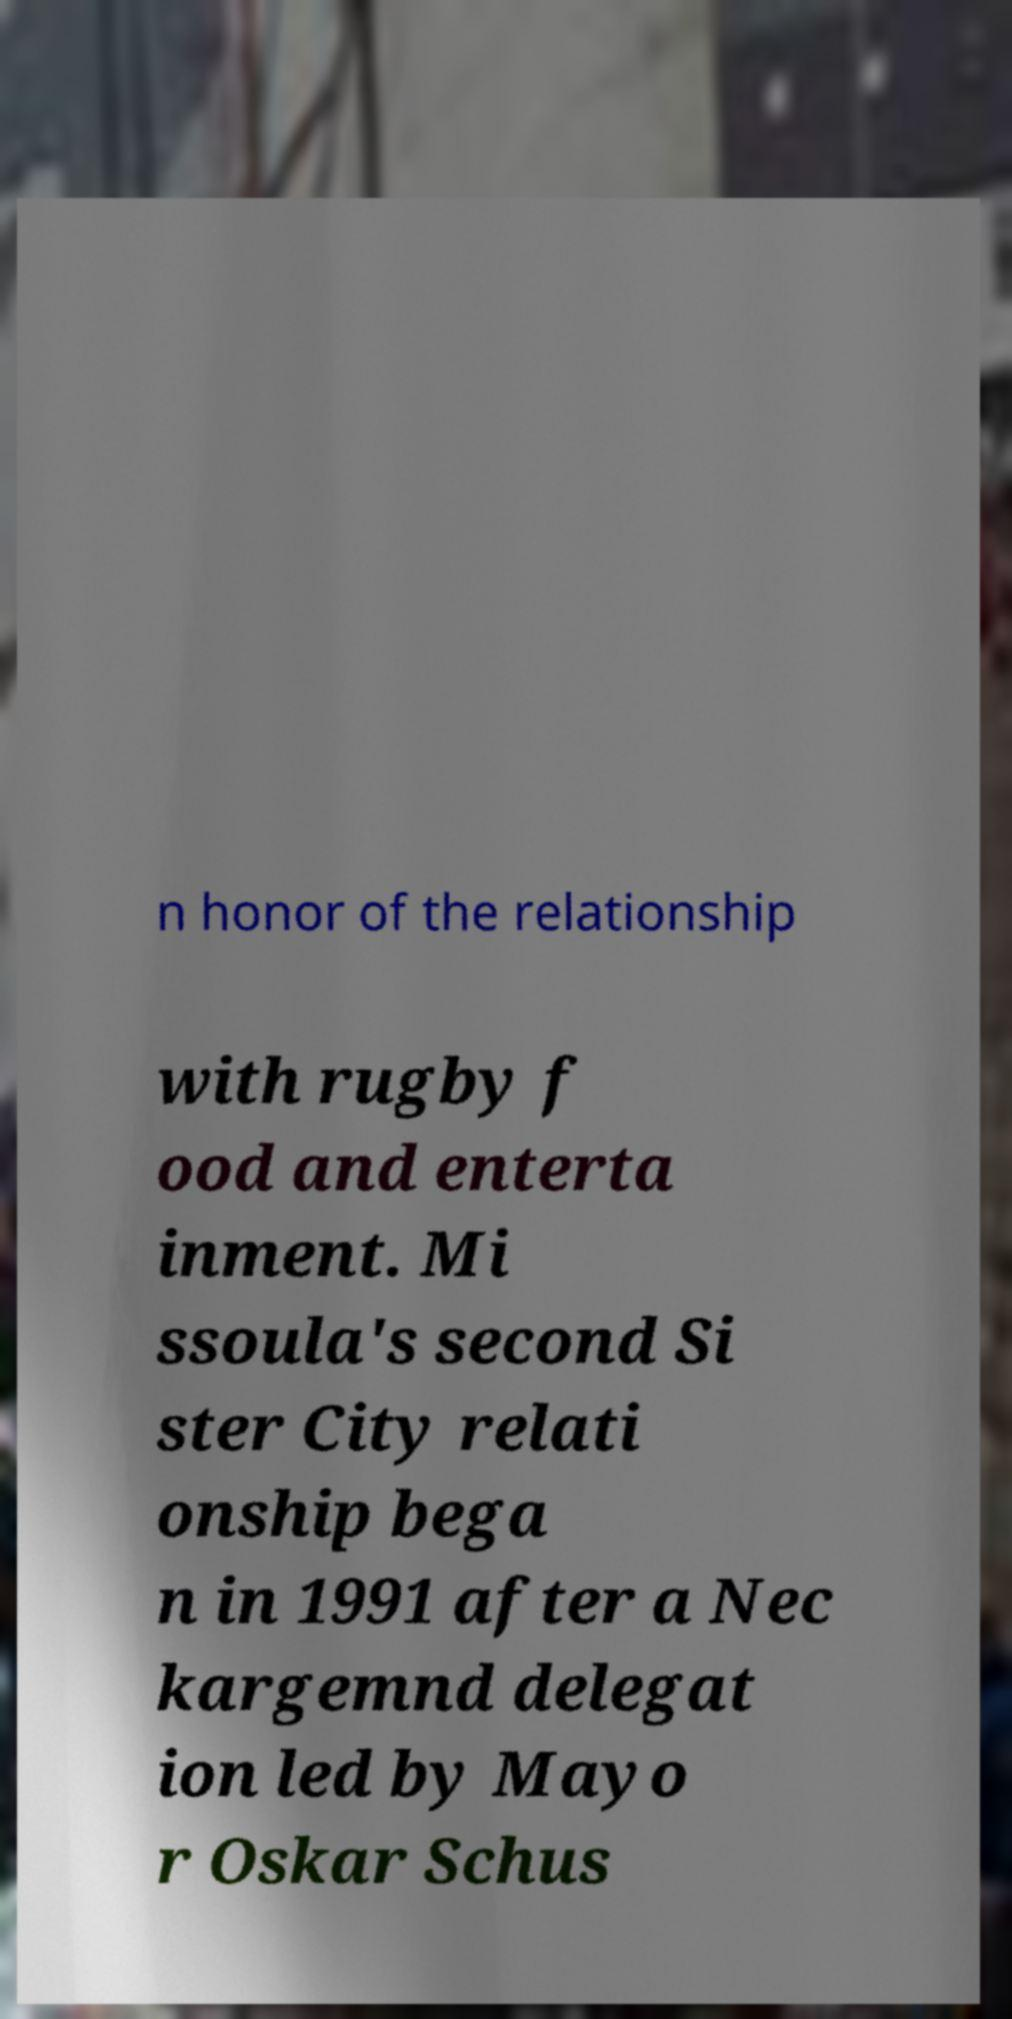Please read and relay the text visible in this image. What does it say? n honor of the relationship with rugby f ood and enterta inment. Mi ssoula's second Si ster City relati onship bega n in 1991 after a Nec kargemnd delegat ion led by Mayo r Oskar Schus 